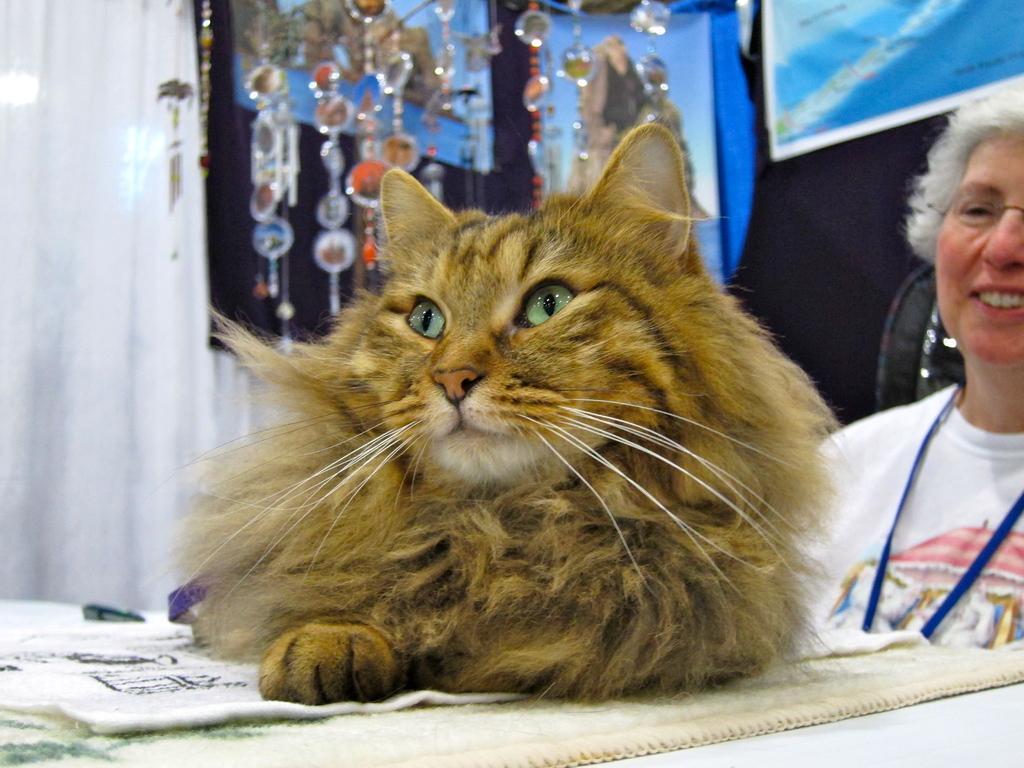Could you give a brief overview of what you see in this image? In this picture we can see a woman,cat and in the background we can see a poster,few more objects. 